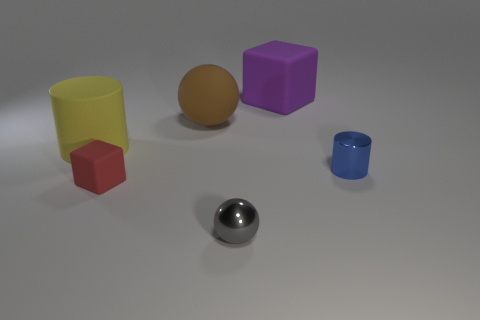There is a cylinder behind the cylinder that is in front of the big cylinder; are there any tiny objects that are behind it?
Ensure brevity in your answer.  No. How many things are either purple matte objects or blue cylinders?
Keep it short and to the point. 2. Is the big yellow cylinder made of the same material as the ball that is right of the brown rubber object?
Provide a succinct answer. No. Are there any other things that are the same color as the tiny cube?
Make the answer very short. No. How many things are either matte things that are on the right side of the shiny sphere or big objects that are in front of the big purple matte object?
Your answer should be compact. 3. There is a large thing that is in front of the purple block and on the right side of the large yellow thing; what shape is it?
Your answer should be very brief. Sphere. There is a metal object behind the red matte block; what number of tiny blue metal things are behind it?
Provide a succinct answer. 0. How many things are large objects left of the gray shiny sphere or blue objects?
Provide a succinct answer. 3. There is a cylinder to the left of the large purple rubber object; how big is it?
Make the answer very short. Large. What is the small gray thing made of?
Provide a short and direct response. Metal. 